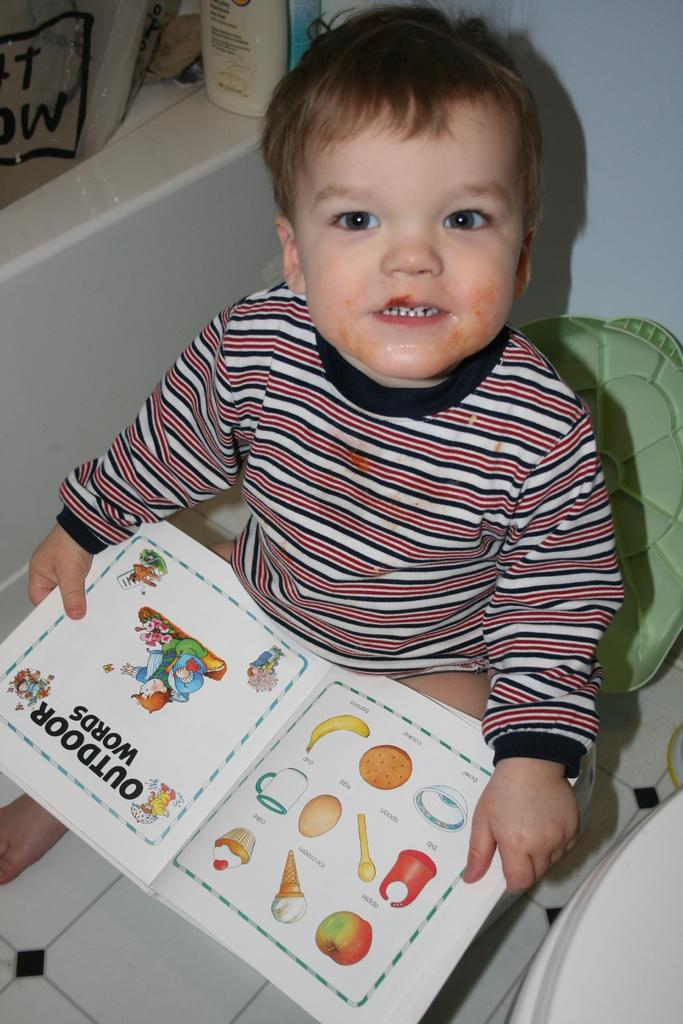What is the main subject of the image? The main subject of the image is a kid. What is the kid holding in the image? The kid is holding a book in the image. What direction is the kid looking in the image? The kid is looking upwards in the image. What other object can be seen in the image? There is a bottle in the image. What is the color of the wall in the background of the image? The wall in the background of the image is white. What type of badge is the maid wearing in the image? There is no maid or badge present in the image. What channel is the kid watching on the television in the image? There is no television present in the image. 